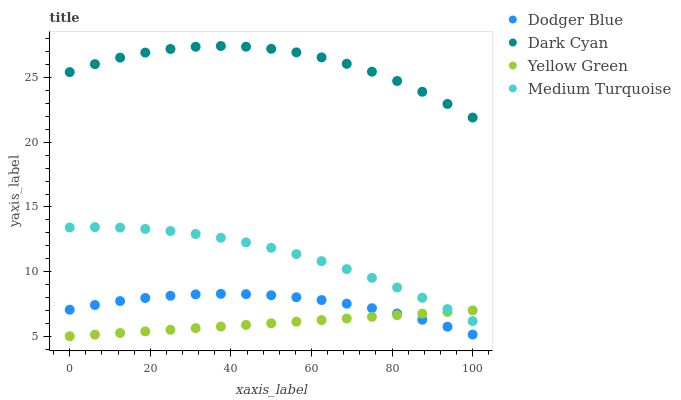Does Yellow Green have the minimum area under the curve?
Answer yes or no. Yes. Does Dark Cyan have the maximum area under the curve?
Answer yes or no. Yes. Does Dodger Blue have the minimum area under the curve?
Answer yes or no. No. Does Dodger Blue have the maximum area under the curve?
Answer yes or no. No. Is Yellow Green the smoothest?
Answer yes or no. Yes. Is Dark Cyan the roughest?
Answer yes or no. Yes. Is Dodger Blue the smoothest?
Answer yes or no. No. Is Dodger Blue the roughest?
Answer yes or no. No. Does Yellow Green have the lowest value?
Answer yes or no. Yes. Does Dodger Blue have the lowest value?
Answer yes or no. No. Does Dark Cyan have the highest value?
Answer yes or no. Yes. Does Dodger Blue have the highest value?
Answer yes or no. No. Is Medium Turquoise less than Dark Cyan?
Answer yes or no. Yes. Is Medium Turquoise greater than Dodger Blue?
Answer yes or no. Yes. Does Yellow Green intersect Dodger Blue?
Answer yes or no. Yes. Is Yellow Green less than Dodger Blue?
Answer yes or no. No. Is Yellow Green greater than Dodger Blue?
Answer yes or no. No. Does Medium Turquoise intersect Dark Cyan?
Answer yes or no. No. 